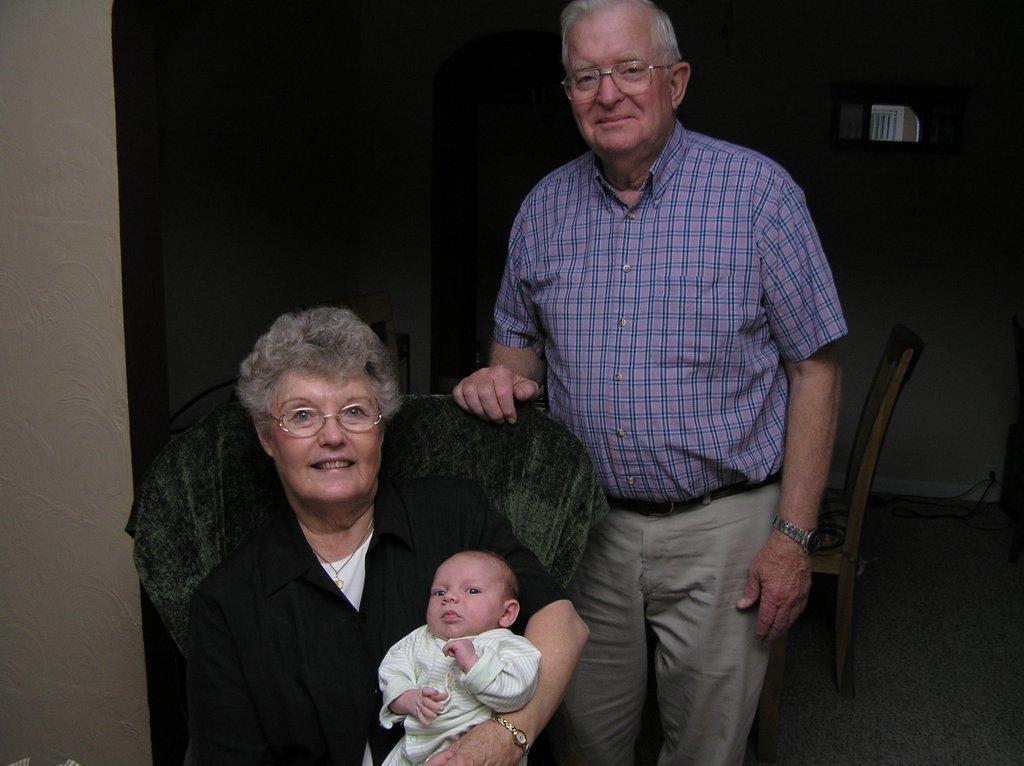Please provide a concise description of this image. In this image I can see one person is sitting on the chair and holding the baby. Back I can see the wall and an another person is standing. 